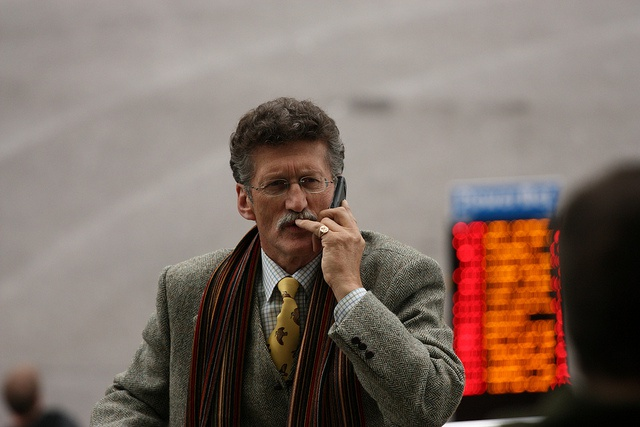Describe the objects in this image and their specific colors. I can see people in darkgray, black, gray, and maroon tones, people in darkgray, black, and gray tones, people in darkgray, black, gray, and maroon tones, tie in darkgray, black, olive, and maroon tones, and cell phone in darkgray, gray, and black tones in this image. 